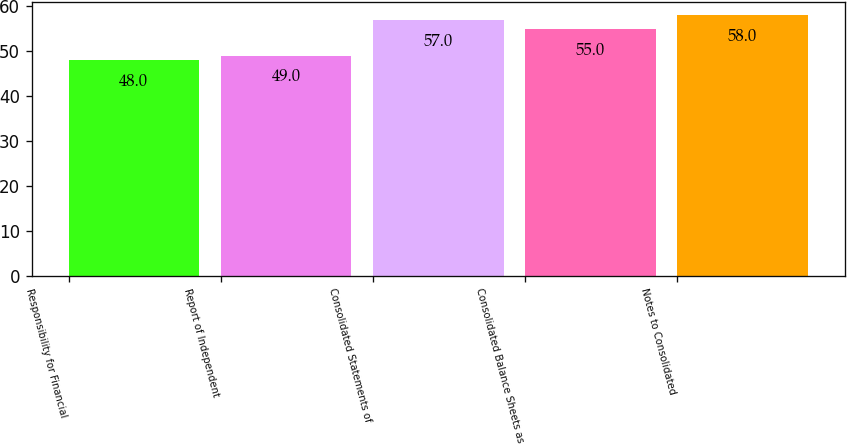Convert chart to OTSL. <chart><loc_0><loc_0><loc_500><loc_500><bar_chart><fcel>Responsibility for Financial<fcel>Report of Independent<fcel>Consolidated Statements of<fcel>Consolidated Balance Sheets as<fcel>Notes to Consolidated<nl><fcel>48<fcel>49<fcel>57<fcel>55<fcel>58<nl></chart> 